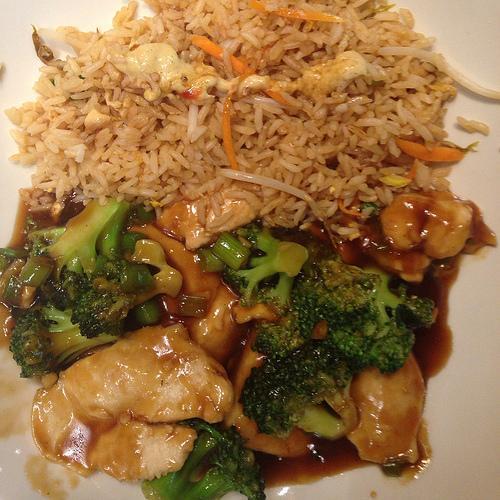How many plates are there?
Give a very brief answer. 1. 